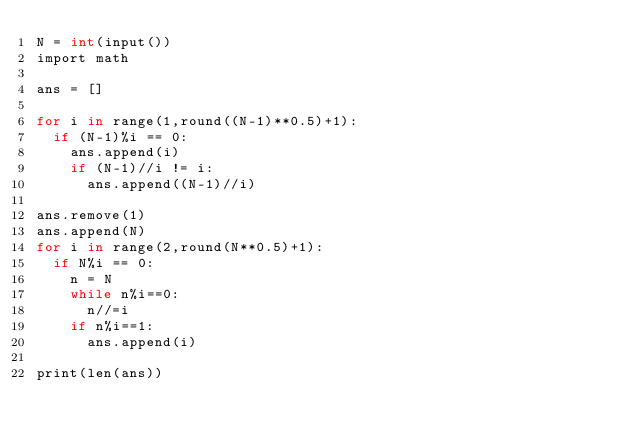<code> <loc_0><loc_0><loc_500><loc_500><_Cython_>N = int(input())
import math

ans = []

for i in range(1,round((N-1)**0.5)+1):
  if (N-1)%i == 0:
    ans.append(i)
    if (N-1)//i != i:
      ans.append((N-1)//i)

ans.remove(1)
ans.append(N)
for i in range(2,round(N**0.5)+1):
  if N%i == 0:
    n = N
    while n%i==0:
      n//=i
    if n%i==1:
      ans.append(i)

print(len(ans))
</code> 